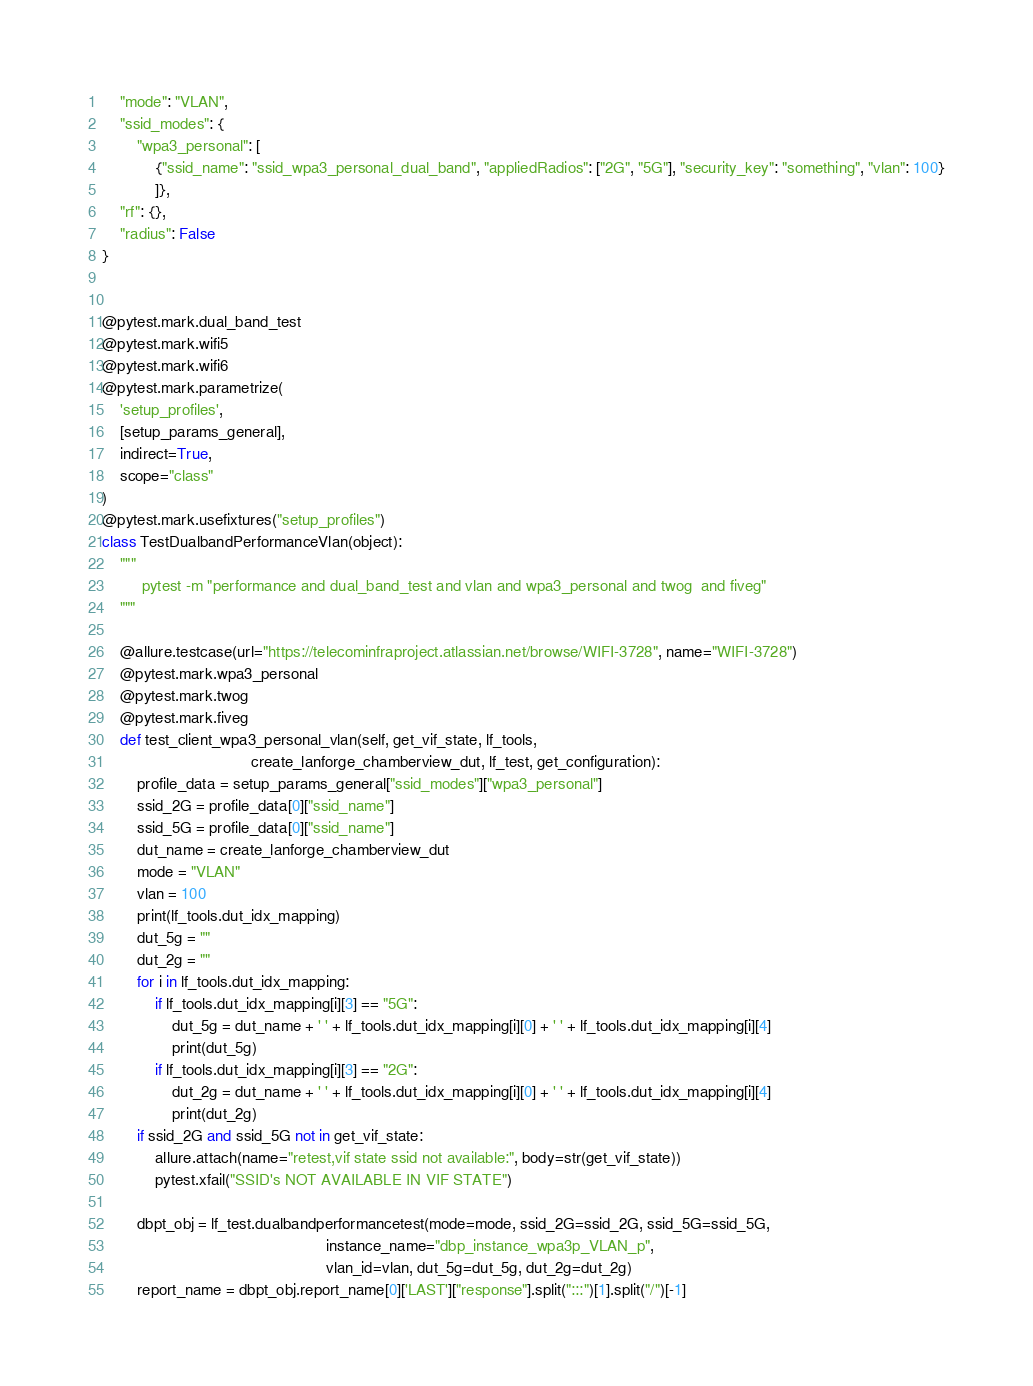<code> <loc_0><loc_0><loc_500><loc_500><_Python_>    "mode": "VLAN",
    "ssid_modes": {
        "wpa3_personal": [
            {"ssid_name": "ssid_wpa3_personal_dual_band", "appliedRadios": ["2G", "5G"], "security_key": "something", "vlan": 100}
            ]},
    "rf": {},
    "radius": False
}


@pytest.mark.dual_band_test
@pytest.mark.wifi5
@pytest.mark.wifi6
@pytest.mark.parametrize(
    'setup_profiles',
    [setup_params_general],
    indirect=True,
    scope="class"
)
@pytest.mark.usefixtures("setup_profiles")
class TestDualbandPerformanceVlan(object):
    """
         pytest -m "performance and dual_band_test and vlan and wpa3_personal and twog  and fiveg"
    """

    @allure.testcase(url="https://telecominfraproject.atlassian.net/browse/WIFI-3728", name="WIFI-3728")
    @pytest.mark.wpa3_personal
    @pytest.mark.twog
    @pytest.mark.fiveg
    def test_client_wpa3_personal_vlan(self, get_vif_state, lf_tools,
                                  create_lanforge_chamberview_dut, lf_test, get_configuration):
        profile_data = setup_params_general["ssid_modes"]["wpa3_personal"]
        ssid_2G = profile_data[0]["ssid_name"]
        ssid_5G = profile_data[0]["ssid_name"]
        dut_name = create_lanforge_chamberview_dut
        mode = "VLAN"
        vlan = 100
        print(lf_tools.dut_idx_mapping)
        dut_5g = ""
        dut_2g = ""
        for i in lf_tools.dut_idx_mapping:
            if lf_tools.dut_idx_mapping[i][3] == "5G":
                dut_5g = dut_name + ' ' + lf_tools.dut_idx_mapping[i][0] + ' ' + lf_tools.dut_idx_mapping[i][4]
                print(dut_5g)
            if lf_tools.dut_idx_mapping[i][3] == "2G":
                dut_2g = dut_name + ' ' + lf_tools.dut_idx_mapping[i][0] + ' ' + lf_tools.dut_idx_mapping[i][4]
                print(dut_2g)
        if ssid_2G and ssid_5G not in get_vif_state:
            allure.attach(name="retest,vif state ssid not available:", body=str(get_vif_state))
            pytest.xfail("SSID's NOT AVAILABLE IN VIF STATE")

        dbpt_obj = lf_test.dualbandperformancetest(mode=mode, ssid_2G=ssid_2G, ssid_5G=ssid_5G,
                                                   instance_name="dbp_instance_wpa3p_VLAN_p",
                                                   vlan_id=vlan, dut_5g=dut_5g, dut_2g=dut_2g)
        report_name = dbpt_obj.report_name[0]['LAST']["response"].split(":::")[1].split("/")[-1]</code> 